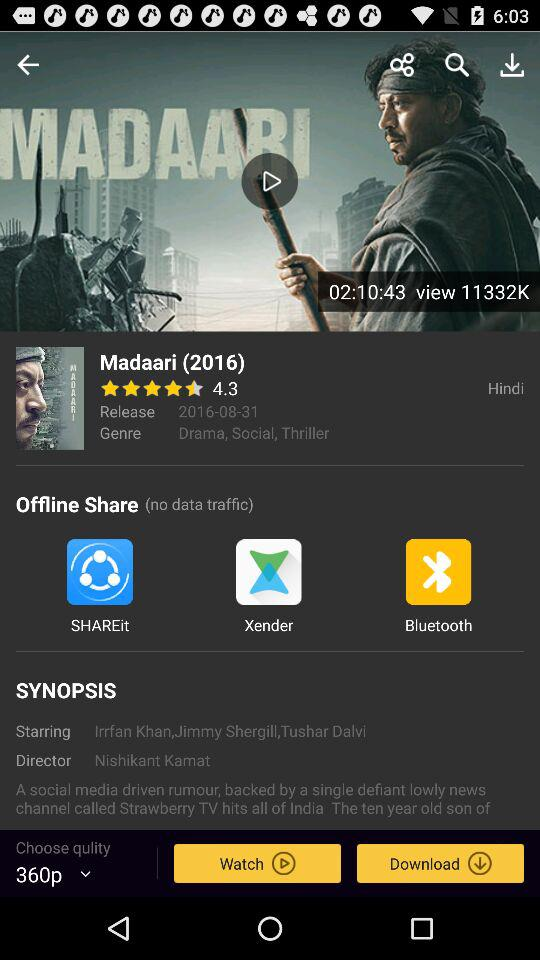What is the star rating of "Madaari"? The rating is 4.3 stars. 